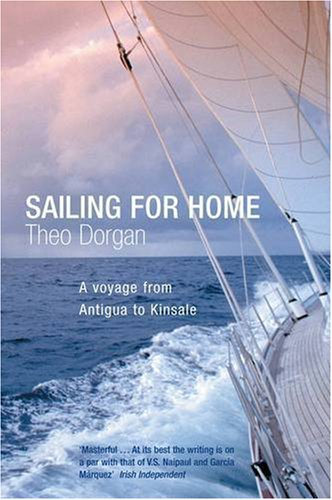Who wrote this book? Theo Dorgan is the author of 'Sailing For Home,' a noted poet and writer, contributing a rich narrative to the travel literature genre. 